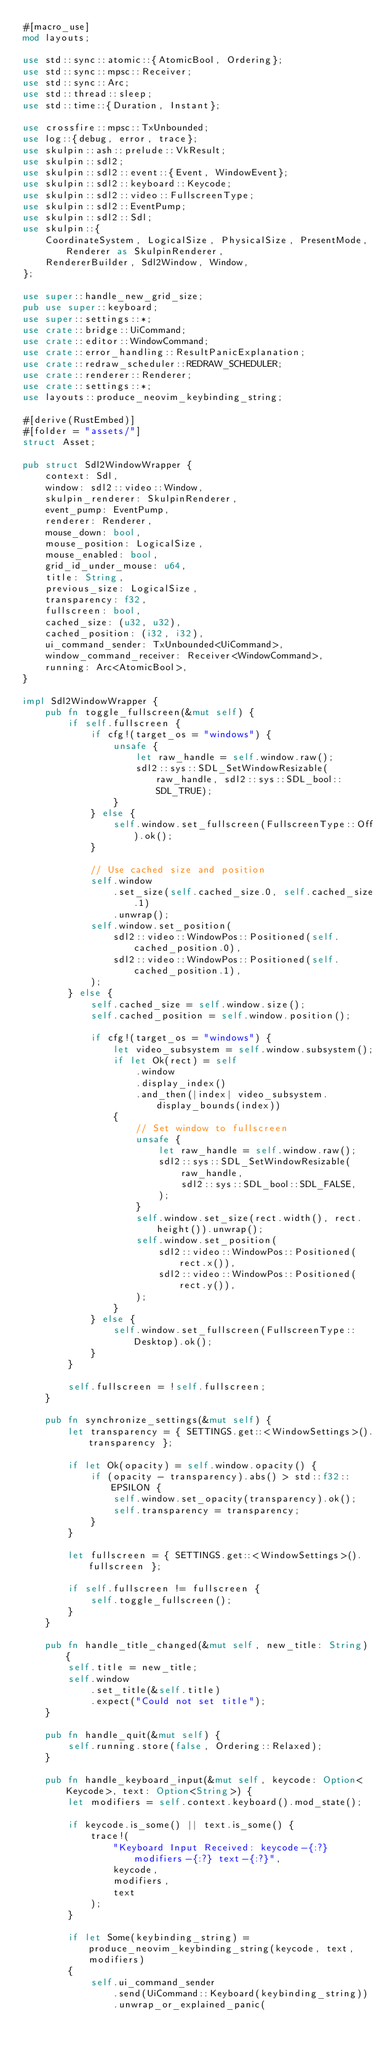Convert code to text. <code><loc_0><loc_0><loc_500><loc_500><_Rust_>#[macro_use]
mod layouts;

use std::sync::atomic::{AtomicBool, Ordering};
use std::sync::mpsc::Receiver;
use std::sync::Arc;
use std::thread::sleep;
use std::time::{Duration, Instant};

use crossfire::mpsc::TxUnbounded;
use log::{debug, error, trace};
use skulpin::ash::prelude::VkResult;
use skulpin::sdl2;
use skulpin::sdl2::event::{Event, WindowEvent};
use skulpin::sdl2::keyboard::Keycode;
use skulpin::sdl2::video::FullscreenType;
use skulpin::sdl2::EventPump;
use skulpin::sdl2::Sdl;
use skulpin::{
    CoordinateSystem, LogicalSize, PhysicalSize, PresentMode, Renderer as SkulpinRenderer,
    RendererBuilder, Sdl2Window, Window,
};

use super::handle_new_grid_size;
pub use super::keyboard;
use super::settings::*;
use crate::bridge::UiCommand;
use crate::editor::WindowCommand;
use crate::error_handling::ResultPanicExplanation;
use crate::redraw_scheduler::REDRAW_SCHEDULER;
use crate::renderer::Renderer;
use crate::settings::*;
use layouts::produce_neovim_keybinding_string;

#[derive(RustEmbed)]
#[folder = "assets/"]
struct Asset;

pub struct Sdl2WindowWrapper {
    context: Sdl,
    window: sdl2::video::Window,
    skulpin_renderer: SkulpinRenderer,
    event_pump: EventPump,
    renderer: Renderer,
    mouse_down: bool,
    mouse_position: LogicalSize,
    mouse_enabled: bool,
    grid_id_under_mouse: u64,
    title: String,
    previous_size: LogicalSize,
    transparency: f32,
    fullscreen: bool,
    cached_size: (u32, u32),
    cached_position: (i32, i32),
    ui_command_sender: TxUnbounded<UiCommand>,
    window_command_receiver: Receiver<WindowCommand>,
    running: Arc<AtomicBool>,
}

impl Sdl2WindowWrapper {
    pub fn toggle_fullscreen(&mut self) {
        if self.fullscreen {
            if cfg!(target_os = "windows") {
                unsafe {
                    let raw_handle = self.window.raw();
                    sdl2::sys::SDL_SetWindowResizable(raw_handle, sdl2::sys::SDL_bool::SDL_TRUE);
                }
            } else {
                self.window.set_fullscreen(FullscreenType::Off).ok();
            }

            // Use cached size and position
            self.window
                .set_size(self.cached_size.0, self.cached_size.1)
                .unwrap();
            self.window.set_position(
                sdl2::video::WindowPos::Positioned(self.cached_position.0),
                sdl2::video::WindowPos::Positioned(self.cached_position.1),
            );
        } else {
            self.cached_size = self.window.size();
            self.cached_position = self.window.position();

            if cfg!(target_os = "windows") {
                let video_subsystem = self.window.subsystem();
                if let Ok(rect) = self
                    .window
                    .display_index()
                    .and_then(|index| video_subsystem.display_bounds(index))
                {
                    // Set window to fullscreen
                    unsafe {
                        let raw_handle = self.window.raw();
                        sdl2::sys::SDL_SetWindowResizable(
                            raw_handle,
                            sdl2::sys::SDL_bool::SDL_FALSE,
                        );
                    }
                    self.window.set_size(rect.width(), rect.height()).unwrap();
                    self.window.set_position(
                        sdl2::video::WindowPos::Positioned(rect.x()),
                        sdl2::video::WindowPos::Positioned(rect.y()),
                    );
                }
            } else {
                self.window.set_fullscreen(FullscreenType::Desktop).ok();
            }
        }

        self.fullscreen = !self.fullscreen;
    }

    pub fn synchronize_settings(&mut self) {
        let transparency = { SETTINGS.get::<WindowSettings>().transparency };

        if let Ok(opacity) = self.window.opacity() {
            if (opacity - transparency).abs() > std::f32::EPSILON {
                self.window.set_opacity(transparency).ok();
                self.transparency = transparency;
            }
        }

        let fullscreen = { SETTINGS.get::<WindowSettings>().fullscreen };

        if self.fullscreen != fullscreen {
            self.toggle_fullscreen();
        }
    }

    pub fn handle_title_changed(&mut self, new_title: String) {
        self.title = new_title;
        self.window
            .set_title(&self.title)
            .expect("Could not set title");
    }

    pub fn handle_quit(&mut self) {
        self.running.store(false, Ordering::Relaxed);
    }

    pub fn handle_keyboard_input(&mut self, keycode: Option<Keycode>, text: Option<String>) {
        let modifiers = self.context.keyboard().mod_state();

        if keycode.is_some() || text.is_some() {
            trace!(
                "Keyboard Input Received: keycode-{:?} modifiers-{:?} text-{:?}",
                keycode,
                modifiers,
                text
            );
        }

        if let Some(keybinding_string) = produce_neovim_keybinding_string(keycode, text, modifiers)
        {
            self.ui_command_sender
                .send(UiCommand::Keyboard(keybinding_string))
                .unwrap_or_explained_panic(</code> 